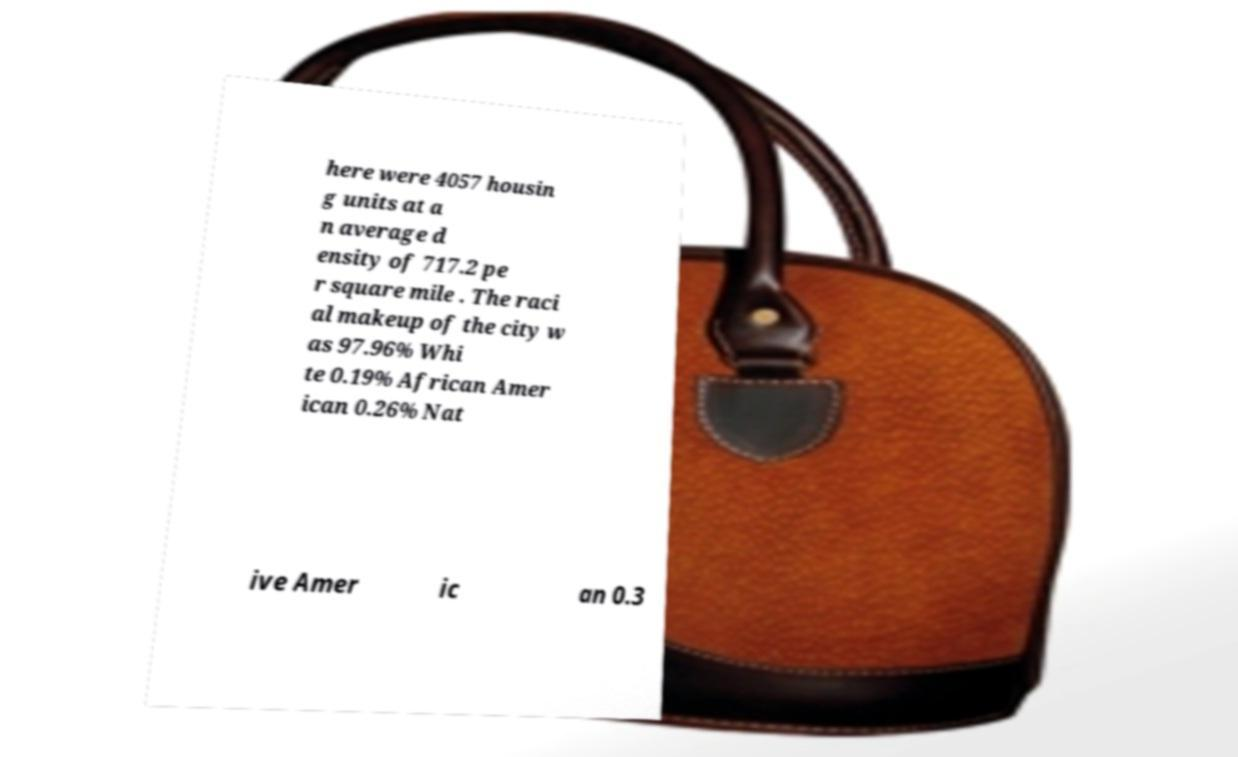Could you assist in decoding the text presented in this image and type it out clearly? here were 4057 housin g units at a n average d ensity of 717.2 pe r square mile . The raci al makeup of the city w as 97.96% Whi te 0.19% African Amer ican 0.26% Nat ive Amer ic an 0.3 